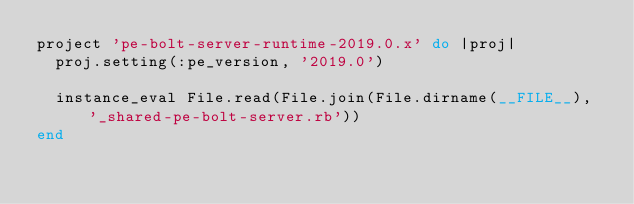Convert code to text. <code><loc_0><loc_0><loc_500><loc_500><_Ruby_>project 'pe-bolt-server-runtime-2019.0.x' do |proj|
  proj.setting(:pe_version, '2019.0')

  instance_eval File.read(File.join(File.dirname(__FILE__), '_shared-pe-bolt-server.rb'))
end

</code> 